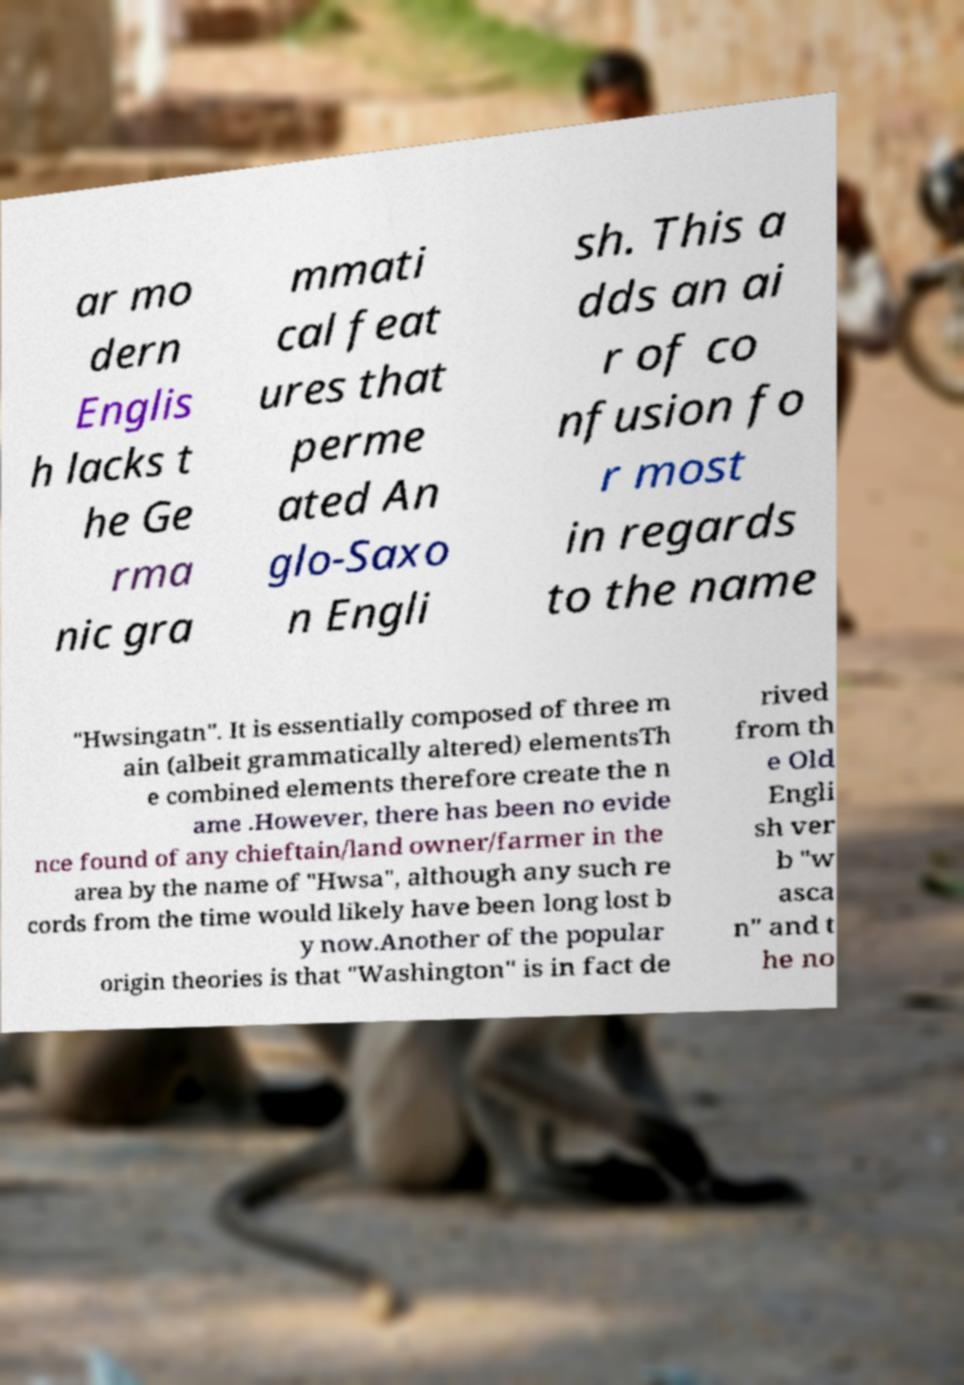Please identify and transcribe the text found in this image. ar mo dern Englis h lacks t he Ge rma nic gra mmati cal feat ures that perme ated An glo-Saxo n Engli sh. This a dds an ai r of co nfusion fo r most in regards to the name "Hwsingatn". It is essentially composed of three m ain (albeit grammatically altered) elementsTh e combined elements therefore create the n ame .However, there has been no evide nce found of any chieftain/land owner/farmer in the area by the name of "Hwsa", although any such re cords from the time would likely have been long lost b y now.Another of the popular origin theories is that "Washington" is in fact de rived from th e Old Engli sh ver b "w asca n" and t he no 